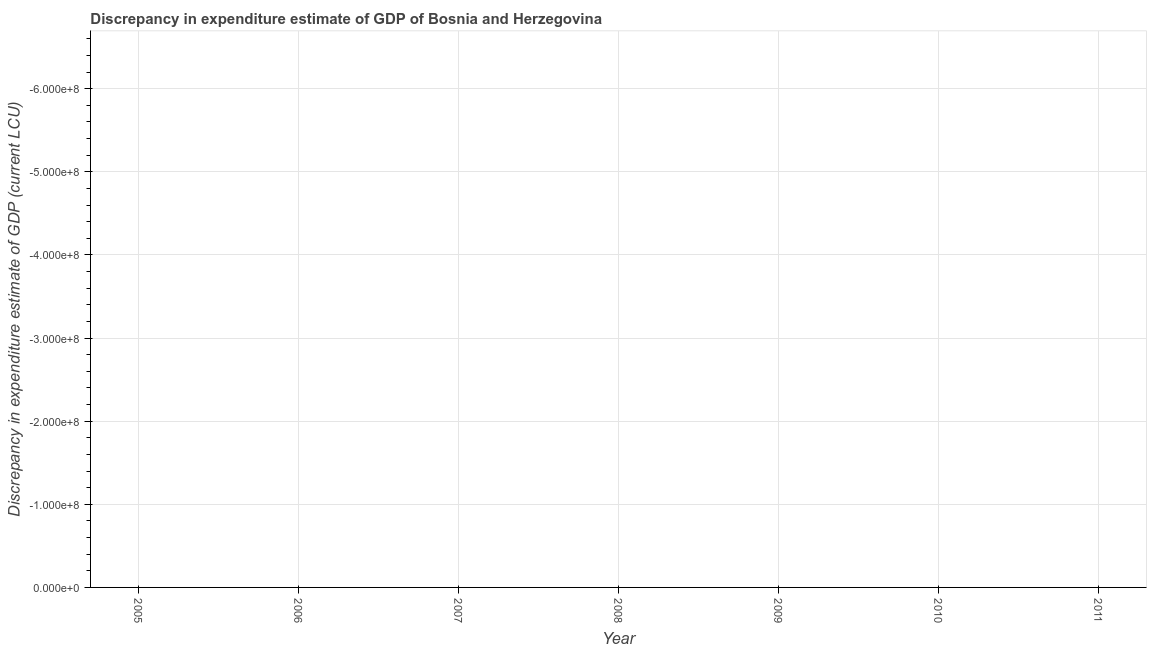What is the discrepancy in expenditure estimate of gdp in 2011?
Your answer should be very brief. 0. Across all years, what is the minimum discrepancy in expenditure estimate of gdp?
Offer a very short reply. 0. What is the sum of the discrepancy in expenditure estimate of gdp?
Provide a short and direct response. 0. What is the average discrepancy in expenditure estimate of gdp per year?
Your answer should be very brief. 0. In how many years, is the discrepancy in expenditure estimate of gdp greater than the average discrepancy in expenditure estimate of gdp taken over all years?
Keep it short and to the point. 0. How many lines are there?
Provide a succinct answer. 0. How many years are there in the graph?
Offer a terse response. 7. Are the values on the major ticks of Y-axis written in scientific E-notation?
Offer a terse response. Yes. What is the title of the graph?
Make the answer very short. Discrepancy in expenditure estimate of GDP of Bosnia and Herzegovina. What is the label or title of the Y-axis?
Offer a terse response. Discrepancy in expenditure estimate of GDP (current LCU). What is the Discrepancy in expenditure estimate of GDP (current LCU) of 2005?
Make the answer very short. 0. What is the Discrepancy in expenditure estimate of GDP (current LCU) in 2008?
Offer a very short reply. 0. What is the Discrepancy in expenditure estimate of GDP (current LCU) of 2011?
Keep it short and to the point. 0. 